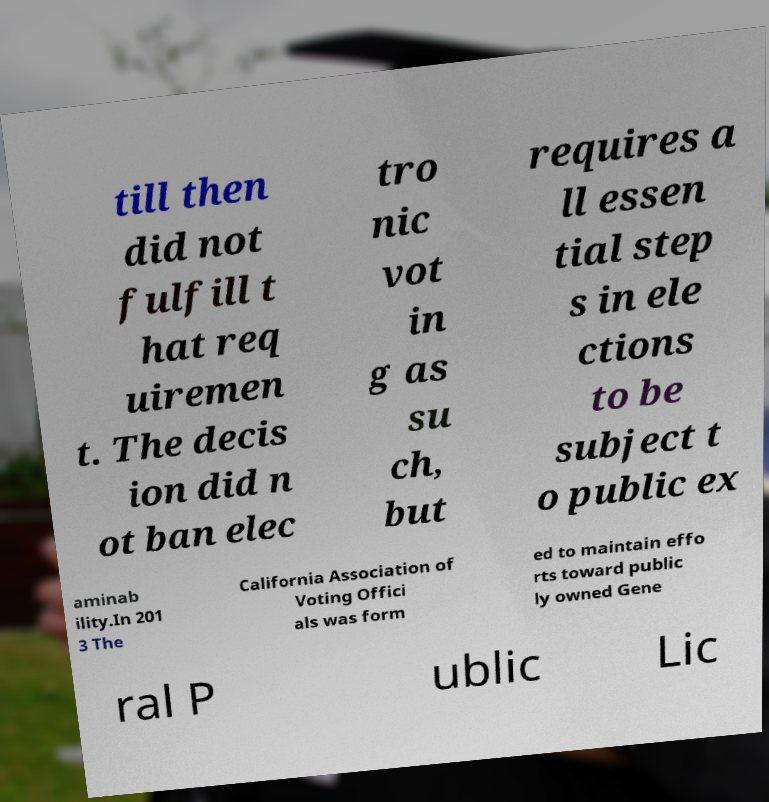Can you accurately transcribe the text from the provided image for me? till then did not fulfill t hat req uiremen t. The decis ion did n ot ban elec tro nic vot in g as su ch, but requires a ll essen tial step s in ele ctions to be subject t o public ex aminab ility.In 201 3 The California Association of Voting Offici als was form ed to maintain effo rts toward public ly owned Gene ral P ublic Lic 